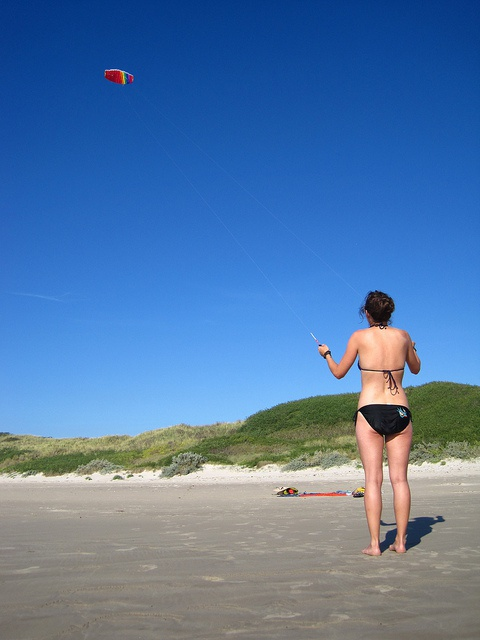Describe the objects in this image and their specific colors. I can see people in darkblue, salmon, black, and tan tones and kite in darkblue, brown, maroon, and darkgray tones in this image. 